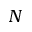Convert formula to latex. <formula><loc_0><loc_0><loc_500><loc_500>N</formula> 